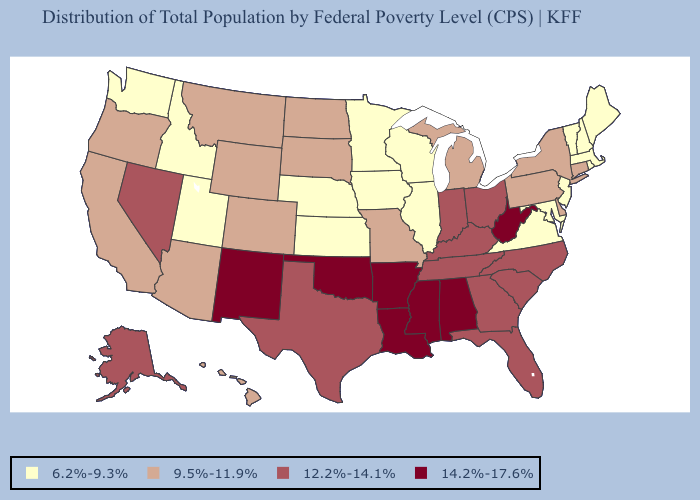Does Delaware have the lowest value in the South?
Write a very short answer. No. How many symbols are there in the legend?
Concise answer only. 4. Name the states that have a value in the range 6.2%-9.3%?
Be succinct. Idaho, Illinois, Iowa, Kansas, Maine, Maryland, Massachusetts, Minnesota, Nebraska, New Hampshire, New Jersey, Rhode Island, Utah, Vermont, Virginia, Washington, Wisconsin. What is the highest value in the South ?
Short answer required. 14.2%-17.6%. Name the states that have a value in the range 9.5%-11.9%?
Be succinct. Arizona, California, Colorado, Connecticut, Delaware, Hawaii, Michigan, Missouri, Montana, New York, North Dakota, Oregon, Pennsylvania, South Dakota, Wyoming. Which states have the lowest value in the MidWest?
Concise answer only. Illinois, Iowa, Kansas, Minnesota, Nebraska, Wisconsin. What is the highest value in the MidWest ?
Keep it brief. 12.2%-14.1%. Among the states that border Illinois , which have the highest value?
Be succinct. Indiana, Kentucky. Name the states that have a value in the range 9.5%-11.9%?
Write a very short answer. Arizona, California, Colorado, Connecticut, Delaware, Hawaii, Michigan, Missouri, Montana, New York, North Dakota, Oregon, Pennsylvania, South Dakota, Wyoming. Which states have the lowest value in the USA?
Give a very brief answer. Idaho, Illinois, Iowa, Kansas, Maine, Maryland, Massachusetts, Minnesota, Nebraska, New Hampshire, New Jersey, Rhode Island, Utah, Vermont, Virginia, Washington, Wisconsin. Does Alaska have the highest value in the USA?
Write a very short answer. No. What is the lowest value in the South?
Short answer required. 6.2%-9.3%. What is the value of New Hampshire?
Give a very brief answer. 6.2%-9.3%. What is the highest value in the South ?
Quick response, please. 14.2%-17.6%. What is the value of Minnesota?
Keep it brief. 6.2%-9.3%. 